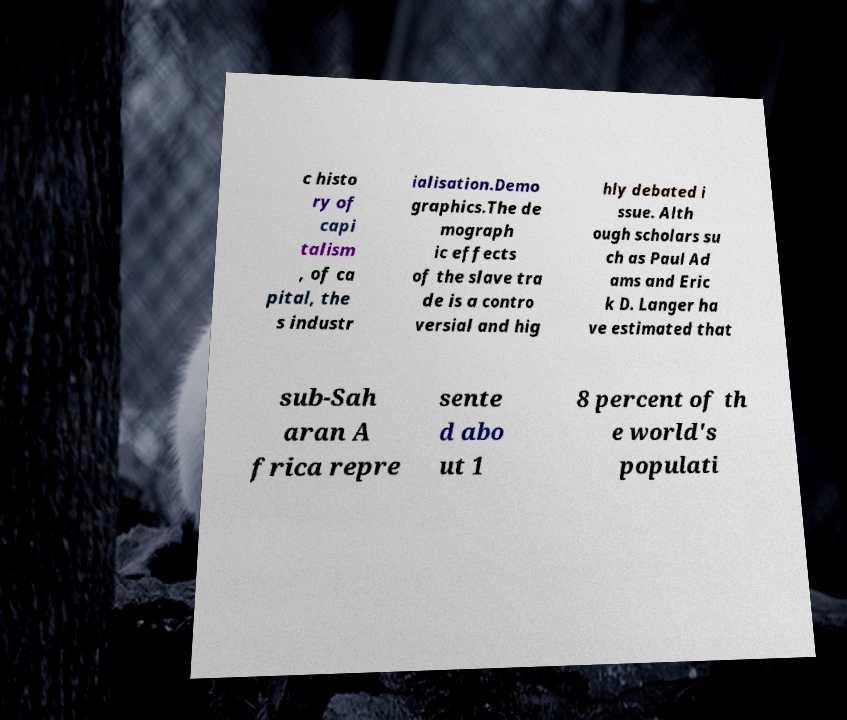Could you assist in decoding the text presented in this image and type it out clearly? c histo ry of capi talism , of ca pital, the s industr ialisation.Demo graphics.The de mograph ic effects of the slave tra de is a contro versial and hig hly debated i ssue. Alth ough scholars su ch as Paul Ad ams and Eric k D. Langer ha ve estimated that sub-Sah aran A frica repre sente d abo ut 1 8 percent of th e world's populati 